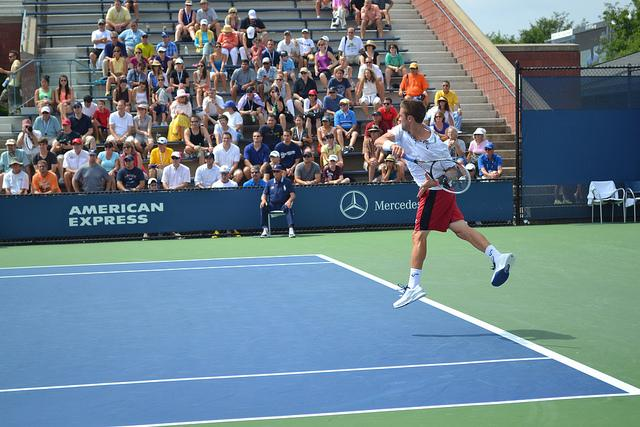Which company has sponsored this event? Please explain your reasoning. american express. The sponsor is in front of the people on the far left. 